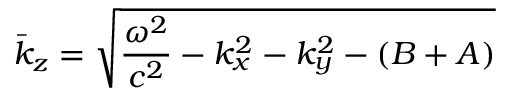Convert formula to latex. <formula><loc_0><loc_0><loc_500><loc_500>\bar { k } _ { z } = \sqrt { \frac { \omega ^ { 2 } } { c ^ { 2 } } - k _ { x } ^ { 2 } - k _ { y } ^ { 2 } - ( B + A ) }</formula> 